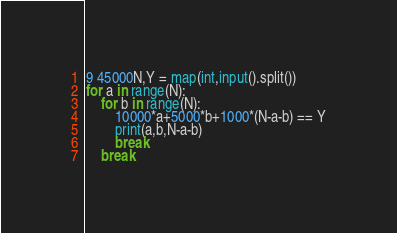<code> <loc_0><loc_0><loc_500><loc_500><_Python_>9 45000N,Y = map(int,input().split())
for a in range(N):
    for b in range(N):
        10000*a+5000*b+1000*(N-a-b) == Y
        print(a,b,N-a-b)
    	break
	break</code> 